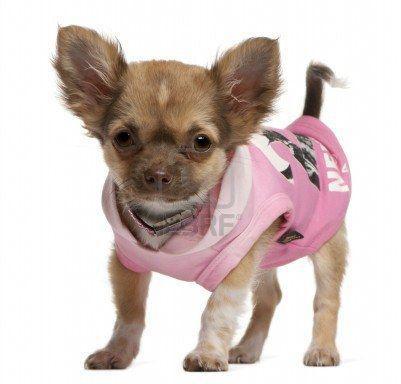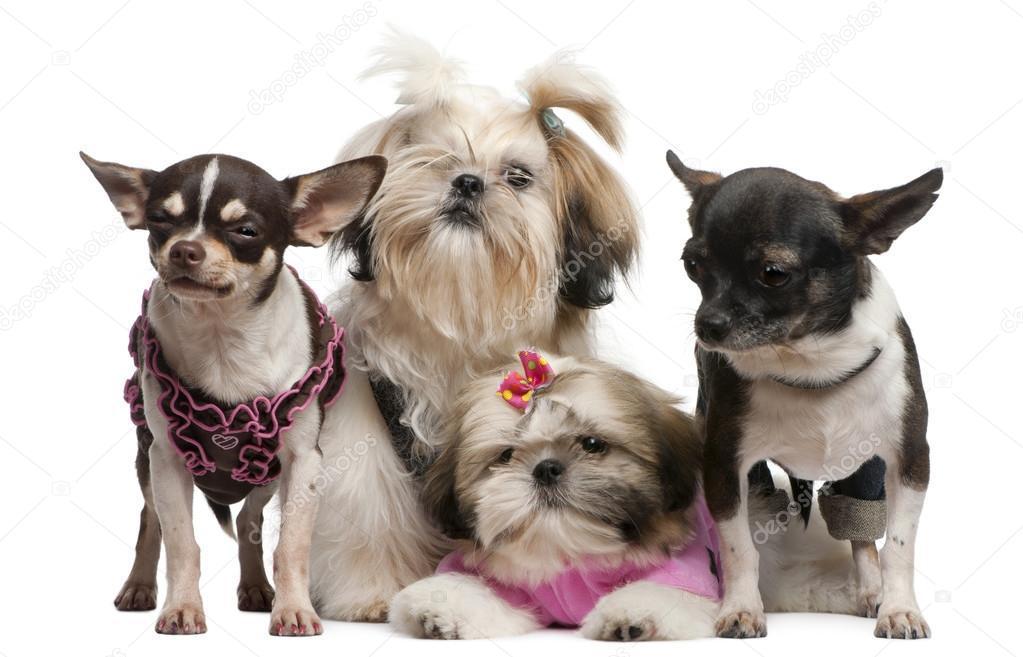The first image is the image on the left, the second image is the image on the right. For the images shown, is this caption "There are more dogs in the image on the right." true? Answer yes or no. Yes. 